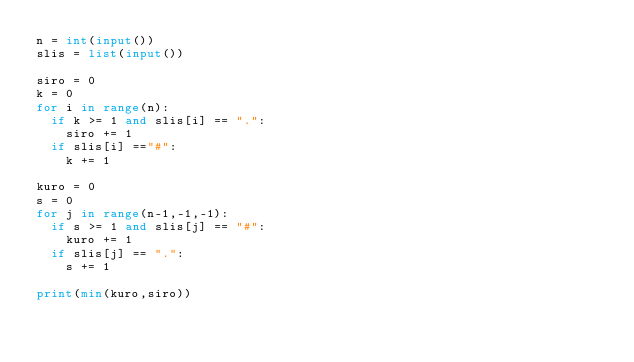<code> <loc_0><loc_0><loc_500><loc_500><_Python_>n = int(input())
slis = list(input())

siro = 0
k = 0
for i in range(n):
  if k >= 1 and slis[i] == ".":
    siro += 1
  if slis[i] =="#":
    k += 1

kuro = 0
s = 0
for j in range(n-1,-1,-1):
  if s >= 1 and slis[j] == "#":
    kuro += 1
  if slis[j] == ".":
    s += 1
    
print(min(kuro,siro))</code> 